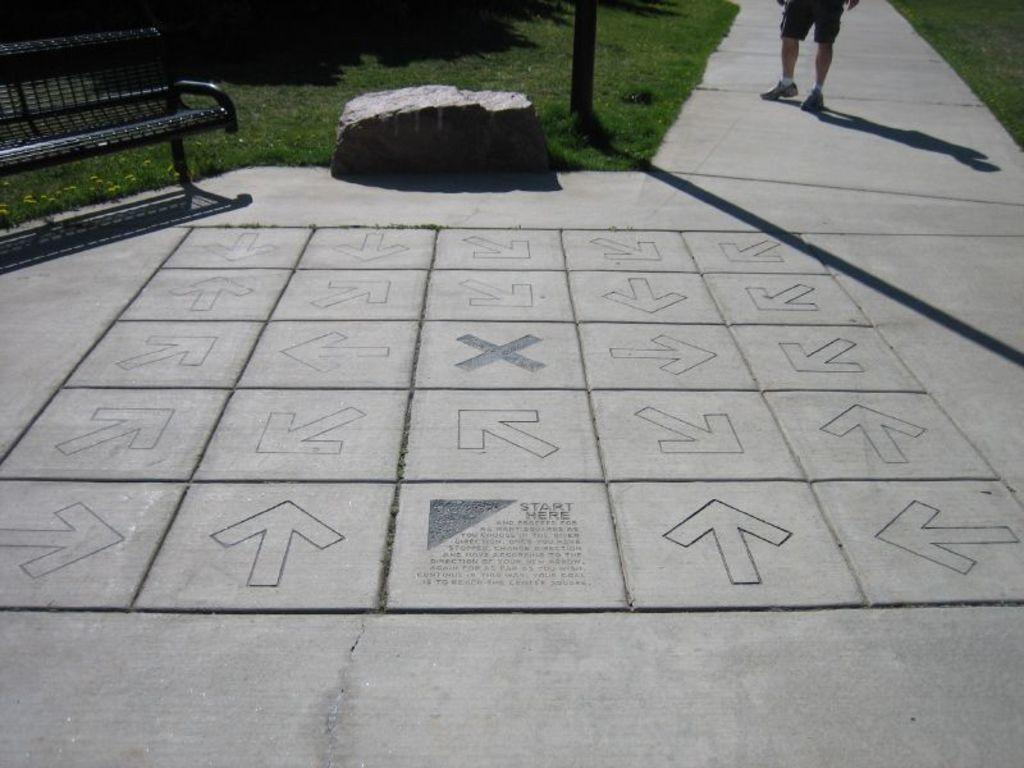What can be found on the floor in the image? There are signs on the floor in the image. What type of seating is present in the image? There is a bench in the image. What natural element is present in the image? There is a rock in the image. What type of vegetation is present in the image? There is grass in the image. What part of a person can be seen in the background of the image? In the background, a person's legs are visible on the ground. What type of substance is being measured by the clock in the image? There is no clock present in the image, so it is not possible to answer that question. 